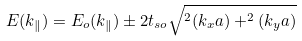Convert formula to latex. <formula><loc_0><loc_0><loc_500><loc_500>E ( { k } _ { \| } ) = E _ { o } ( { k } _ { \| } ) \pm 2 t _ { s o } \sqrt { ^ { 2 } ( k _ { x } a ) + ^ { 2 } ( k _ { y } a ) }</formula> 